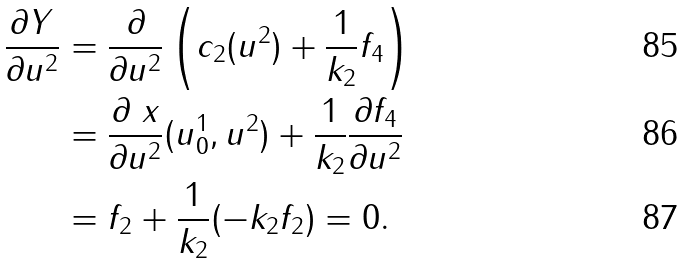<formula> <loc_0><loc_0><loc_500><loc_500>\frac { \partial Y } { \partial u ^ { 2 } } & = \frac { \partial } { \partial u ^ { 2 } } \left ( c _ { 2 } ( u ^ { 2 } ) + \frac { 1 } { k _ { 2 } } f _ { 4 } \right ) \\ & = \frac { \partial \ x } { \partial u ^ { 2 } } ( u _ { 0 } ^ { 1 } , u ^ { 2 } ) + \frac { 1 } { k _ { 2 } } \frac { \partial f _ { 4 } } { \partial u ^ { 2 } } \\ & = f _ { 2 } + \frac { 1 } { k _ { 2 } } ( - k _ { 2 } f _ { 2 } ) = 0 .</formula> 